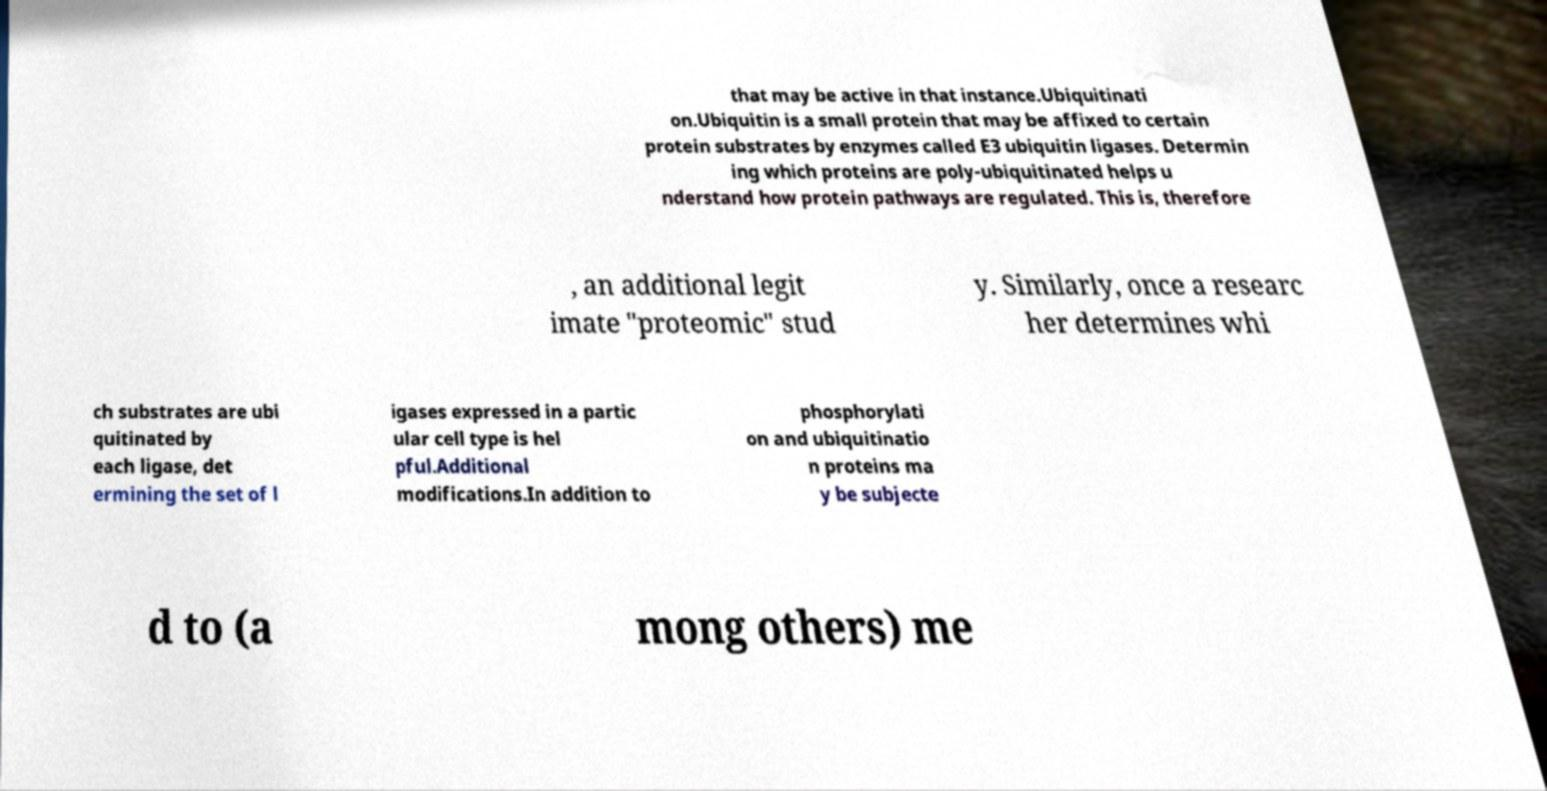What messages or text are displayed in this image? I need them in a readable, typed format. that may be active in that instance.Ubiquitinati on.Ubiquitin is a small protein that may be affixed to certain protein substrates by enzymes called E3 ubiquitin ligases. Determin ing which proteins are poly-ubiquitinated helps u nderstand how protein pathways are regulated. This is, therefore , an additional legit imate "proteomic" stud y. Similarly, once a researc her determines whi ch substrates are ubi quitinated by each ligase, det ermining the set of l igases expressed in a partic ular cell type is hel pful.Additional modifications.In addition to phosphorylati on and ubiquitinatio n proteins ma y be subjecte d to (a mong others) me 